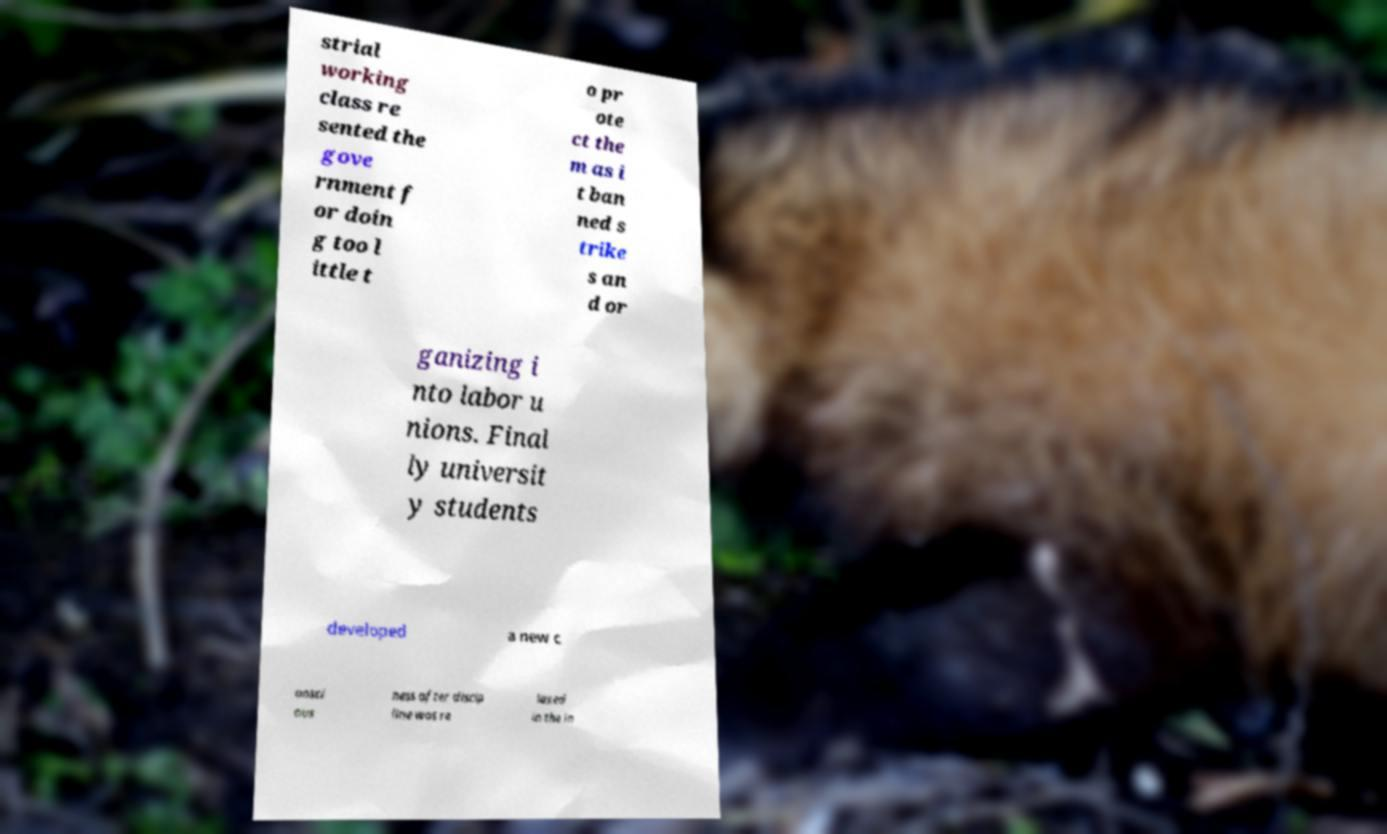There's text embedded in this image that I need extracted. Can you transcribe it verbatim? strial working class re sented the gove rnment f or doin g too l ittle t o pr ote ct the m as i t ban ned s trike s an d or ganizing i nto labor u nions. Final ly universit y students developed a new c onsci ous ness after discip line was re laxed in the in 